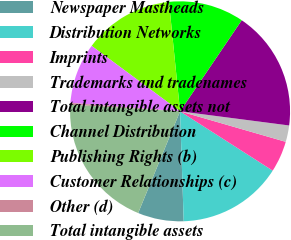Convert chart. <chart><loc_0><loc_0><loc_500><loc_500><pie_chart><fcel>Newspaper Mastheads<fcel>Distribution Networks<fcel>Imprints<fcel>Trademarks and tradenames<fcel>Total intangible assets not<fcel>Channel Distribution<fcel>Publishing Rights (b)<fcel>Customer Relationships (c)<fcel>Other (d)<fcel>Total intangible assets<nl><fcel>6.75%<fcel>15.41%<fcel>4.59%<fcel>2.42%<fcel>17.58%<fcel>11.08%<fcel>13.25%<fcel>8.92%<fcel>0.26%<fcel>19.74%<nl></chart> 